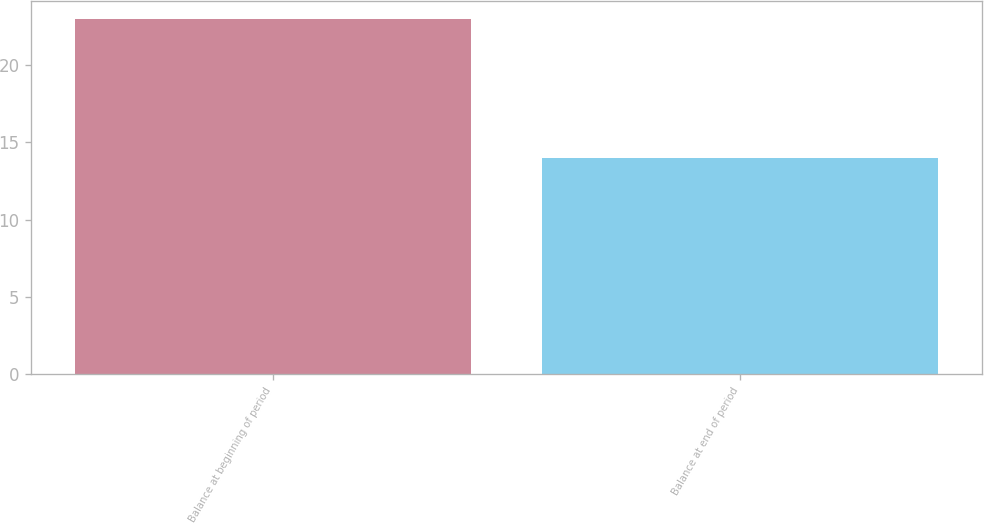<chart> <loc_0><loc_0><loc_500><loc_500><bar_chart><fcel>Balance at beginning of period<fcel>Balance at end of period<nl><fcel>23<fcel>14<nl></chart> 